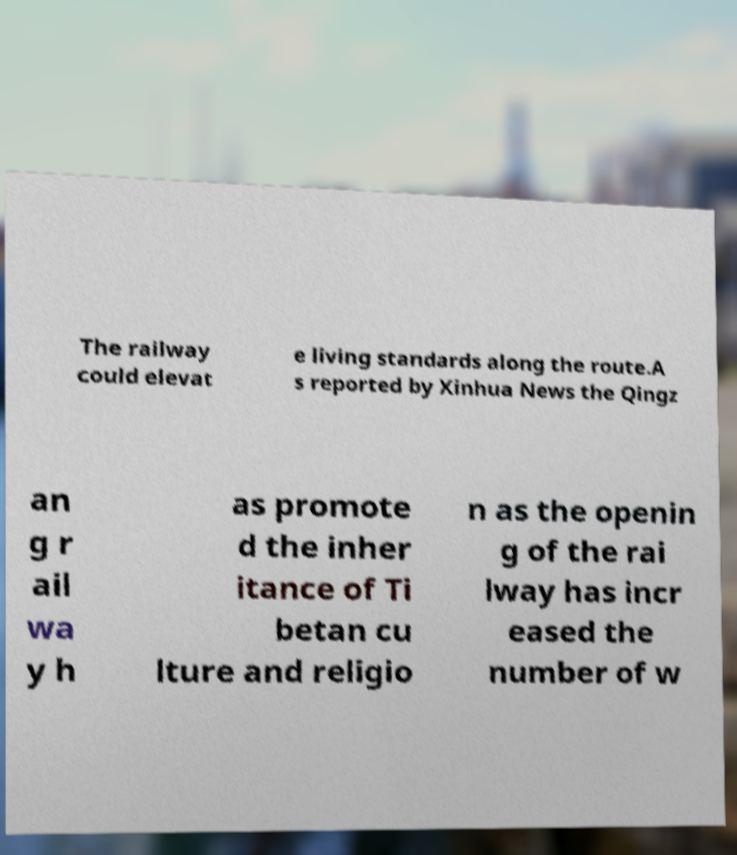Could you assist in decoding the text presented in this image and type it out clearly? The railway could elevat e living standards along the route.A s reported by Xinhua News the Qingz an g r ail wa y h as promote d the inher itance of Ti betan cu lture and religio n as the openin g of the rai lway has incr eased the number of w 